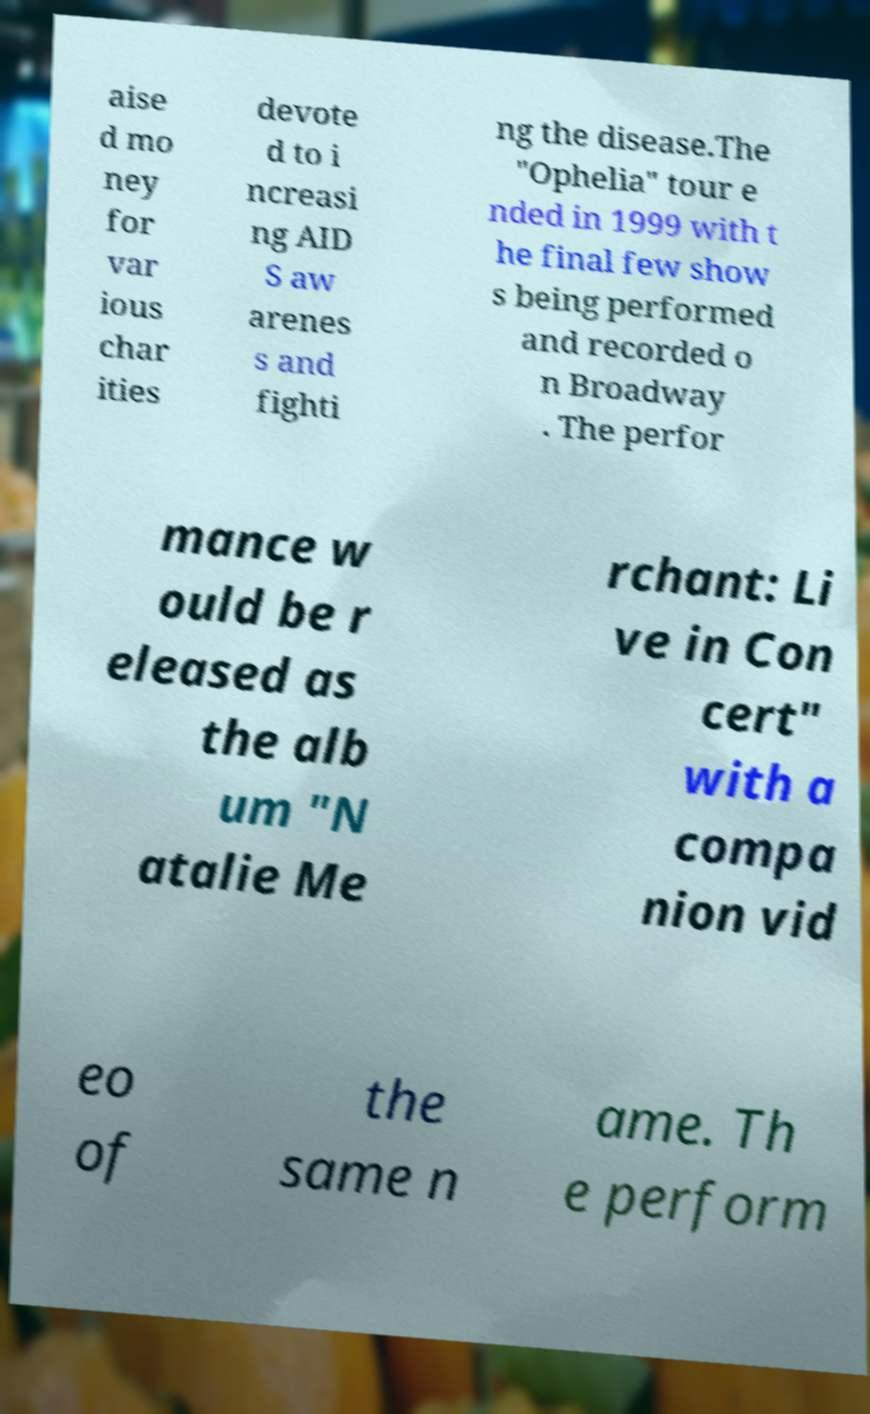I need the written content from this picture converted into text. Can you do that? aise d mo ney for var ious char ities devote d to i ncreasi ng AID S aw arenes s and fighti ng the disease.The "Ophelia" tour e nded in 1999 with t he final few show s being performed and recorded o n Broadway . The perfor mance w ould be r eleased as the alb um "N atalie Me rchant: Li ve in Con cert" with a compa nion vid eo of the same n ame. Th e perform 